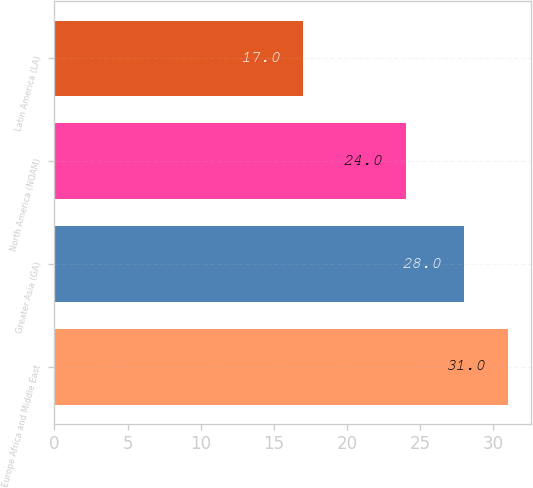Convert chart to OTSL. <chart><loc_0><loc_0><loc_500><loc_500><bar_chart><fcel>Europe Africa and Middle East<fcel>Greater Asia (GA)<fcel>North America (NOAM)<fcel>Latin America (LA)<nl><fcel>31<fcel>28<fcel>24<fcel>17<nl></chart> 